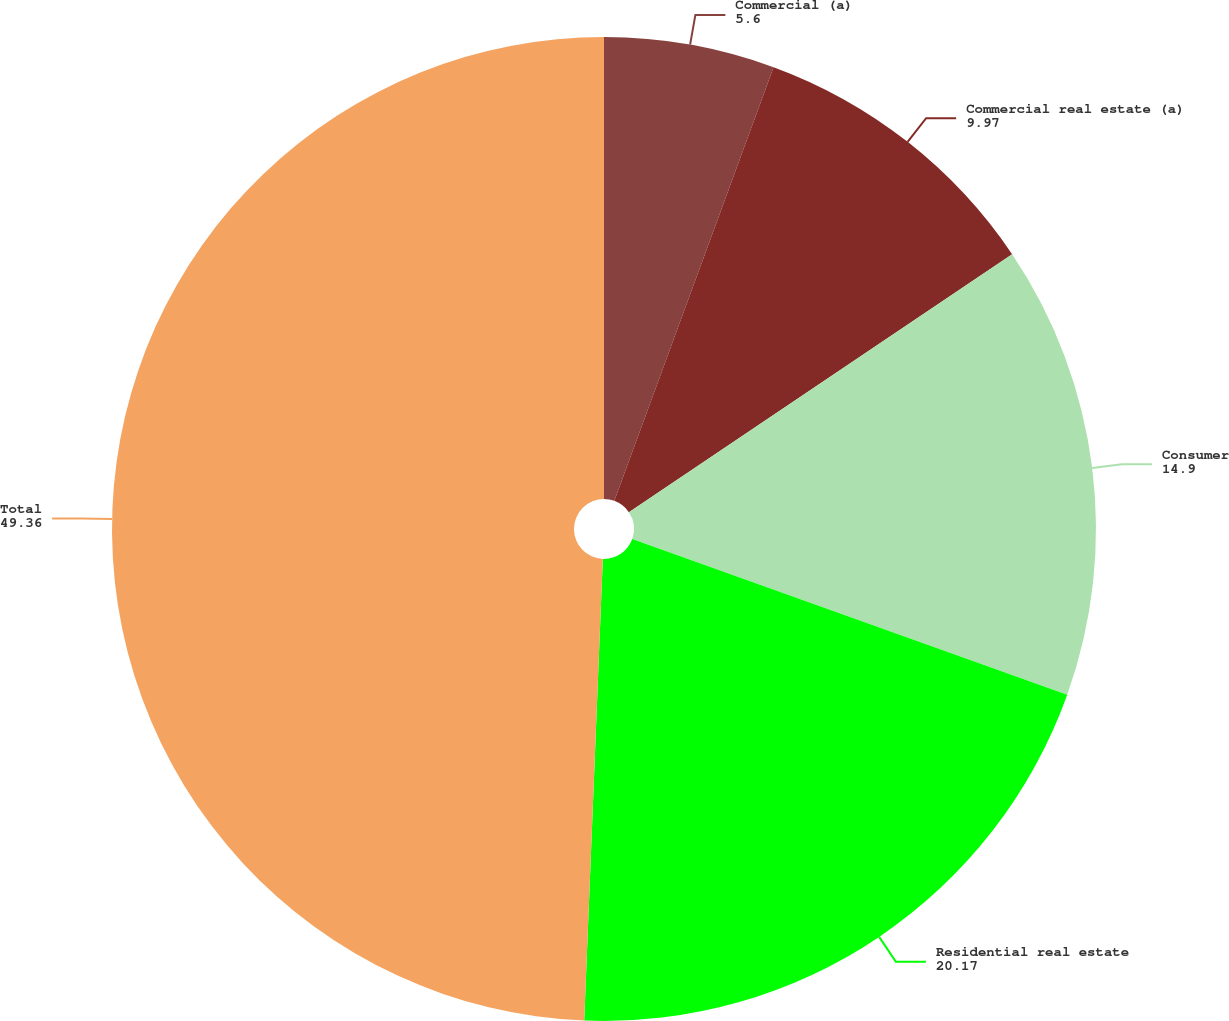<chart> <loc_0><loc_0><loc_500><loc_500><pie_chart><fcel>Commercial (a)<fcel>Commercial real estate (a)<fcel>Consumer<fcel>Residential real estate<fcel>Total<nl><fcel>5.6%<fcel>9.97%<fcel>14.9%<fcel>20.17%<fcel>49.36%<nl></chart> 